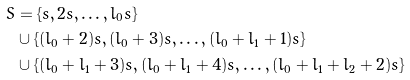<formula> <loc_0><loc_0><loc_500><loc_500>S & = \{ s , 2 s , \dots , l _ { 0 } s \} \\ & \cup \{ ( l _ { 0 } + 2 ) s , ( l _ { 0 } + 3 ) s , \dots , ( l _ { 0 } + l _ { 1 } + 1 ) s \} \\ & \cup \{ ( l _ { 0 } + l _ { 1 } + 3 ) s , ( l _ { 0 } + l _ { 1 } + 4 ) s , \dots , ( l _ { 0 } + l _ { 1 } + l _ { 2 } + 2 ) s \}</formula> 